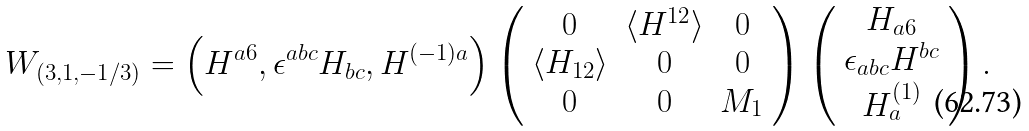Convert formula to latex. <formula><loc_0><loc_0><loc_500><loc_500>W _ { ( 3 , 1 , - 1 / 3 ) } = \left ( H ^ { a 6 } , \epsilon ^ { a b c } H _ { b c } , H ^ { ( - 1 ) a } \right ) \left ( \begin{array} { c c c } 0 & \langle H ^ { 1 2 } \rangle & 0 \\ \langle H _ { 1 2 } \rangle & 0 & 0 \\ 0 & 0 & M _ { 1 } \end{array} \right ) \left ( \begin{array} { c } H _ { a 6 } \\ \epsilon _ { a b c } H ^ { b c } \\ H ^ { ( 1 ) } _ { a } \end{array} \right ) .</formula> 